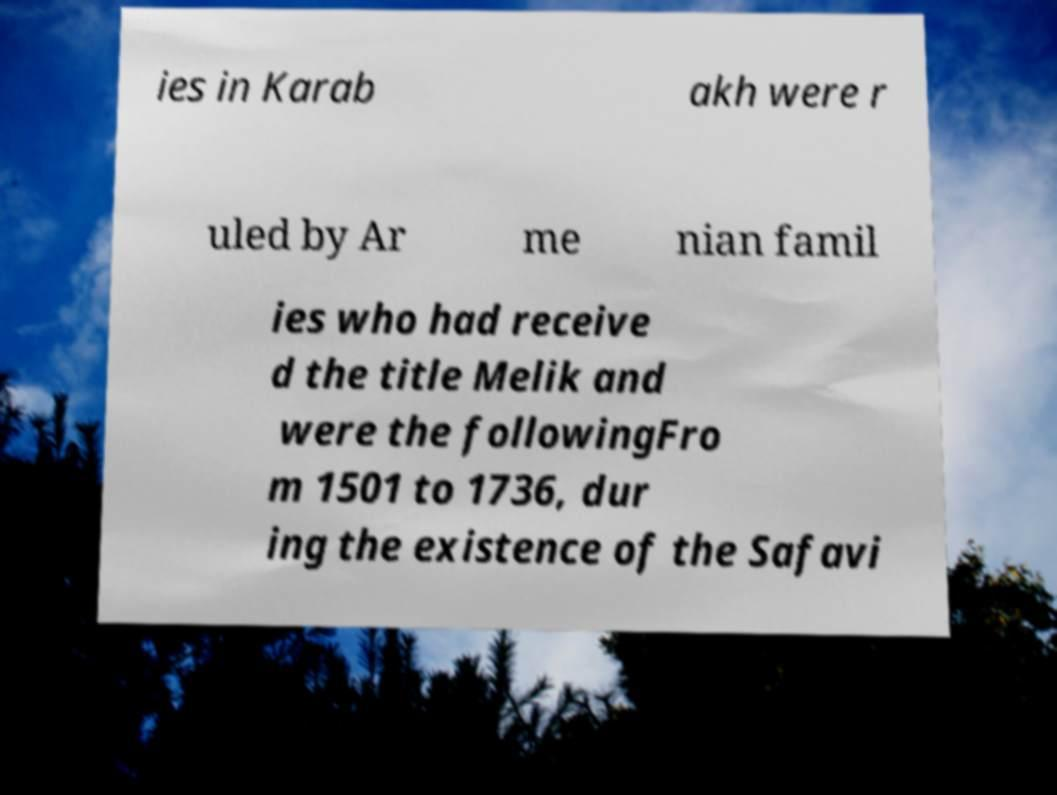For documentation purposes, I need the text within this image transcribed. Could you provide that? ies in Karab akh were r uled by Ar me nian famil ies who had receive d the title Melik and were the followingFro m 1501 to 1736, dur ing the existence of the Safavi 